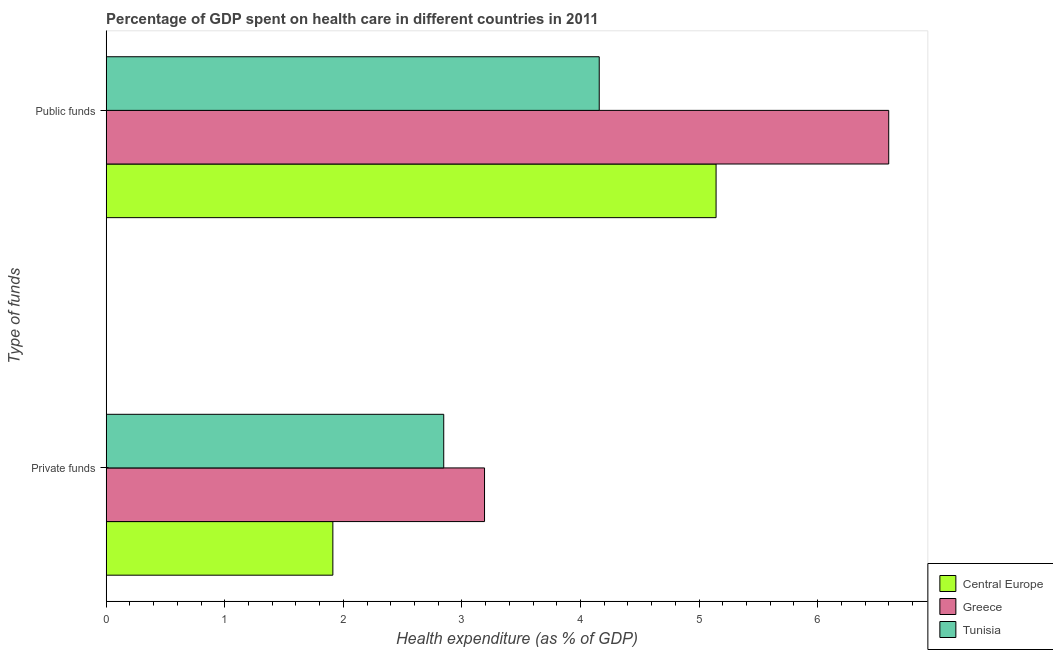How many different coloured bars are there?
Offer a terse response. 3. How many groups of bars are there?
Provide a short and direct response. 2. How many bars are there on the 2nd tick from the bottom?
Make the answer very short. 3. What is the label of the 2nd group of bars from the top?
Ensure brevity in your answer.  Private funds. What is the amount of public funds spent in healthcare in Greece?
Make the answer very short. 6.6. Across all countries, what is the maximum amount of private funds spent in healthcare?
Offer a very short reply. 3.19. Across all countries, what is the minimum amount of public funds spent in healthcare?
Offer a terse response. 4.16. In which country was the amount of private funds spent in healthcare minimum?
Provide a succinct answer. Central Europe. What is the total amount of public funds spent in healthcare in the graph?
Provide a succinct answer. 15.9. What is the difference between the amount of public funds spent in healthcare in Tunisia and that in Greece?
Provide a succinct answer. -2.44. What is the difference between the amount of private funds spent in healthcare in Central Europe and the amount of public funds spent in healthcare in Tunisia?
Your answer should be compact. -2.25. What is the average amount of public funds spent in healthcare per country?
Offer a terse response. 5.3. What is the difference between the amount of public funds spent in healthcare and amount of private funds spent in healthcare in Tunisia?
Give a very brief answer. 1.31. What is the ratio of the amount of private funds spent in healthcare in Greece to that in Central Europe?
Provide a short and direct response. 1.67. What does the 1st bar from the top in Public funds represents?
Your answer should be very brief. Tunisia. What does the 3rd bar from the bottom in Public funds represents?
Your response must be concise. Tunisia. How many bars are there?
Make the answer very short. 6. Are all the bars in the graph horizontal?
Keep it short and to the point. Yes. Are the values on the major ticks of X-axis written in scientific E-notation?
Ensure brevity in your answer.  No. Does the graph contain any zero values?
Keep it short and to the point. No. Does the graph contain grids?
Your response must be concise. No. How many legend labels are there?
Your answer should be very brief. 3. How are the legend labels stacked?
Provide a succinct answer. Vertical. What is the title of the graph?
Give a very brief answer. Percentage of GDP spent on health care in different countries in 2011. Does "Belgium" appear as one of the legend labels in the graph?
Make the answer very short. No. What is the label or title of the X-axis?
Keep it short and to the point. Health expenditure (as % of GDP). What is the label or title of the Y-axis?
Provide a short and direct response. Type of funds. What is the Health expenditure (as % of GDP) in Central Europe in Private funds?
Your answer should be very brief. 1.91. What is the Health expenditure (as % of GDP) of Greece in Private funds?
Offer a very short reply. 3.19. What is the Health expenditure (as % of GDP) of Tunisia in Private funds?
Offer a terse response. 2.85. What is the Health expenditure (as % of GDP) in Central Europe in Public funds?
Offer a terse response. 5.14. What is the Health expenditure (as % of GDP) of Greece in Public funds?
Offer a very short reply. 6.6. What is the Health expenditure (as % of GDP) of Tunisia in Public funds?
Your response must be concise. 4.16. Across all Type of funds, what is the maximum Health expenditure (as % of GDP) in Central Europe?
Provide a succinct answer. 5.14. Across all Type of funds, what is the maximum Health expenditure (as % of GDP) in Greece?
Keep it short and to the point. 6.6. Across all Type of funds, what is the maximum Health expenditure (as % of GDP) of Tunisia?
Your answer should be compact. 4.16. Across all Type of funds, what is the minimum Health expenditure (as % of GDP) of Central Europe?
Offer a very short reply. 1.91. Across all Type of funds, what is the minimum Health expenditure (as % of GDP) of Greece?
Give a very brief answer. 3.19. Across all Type of funds, what is the minimum Health expenditure (as % of GDP) of Tunisia?
Provide a short and direct response. 2.85. What is the total Health expenditure (as % of GDP) of Central Europe in the graph?
Your response must be concise. 7.05. What is the total Health expenditure (as % of GDP) of Greece in the graph?
Make the answer very short. 9.79. What is the total Health expenditure (as % of GDP) in Tunisia in the graph?
Provide a short and direct response. 7. What is the difference between the Health expenditure (as % of GDP) in Central Europe in Private funds and that in Public funds?
Your answer should be compact. -3.23. What is the difference between the Health expenditure (as % of GDP) of Greece in Private funds and that in Public funds?
Your answer should be very brief. -3.41. What is the difference between the Health expenditure (as % of GDP) in Tunisia in Private funds and that in Public funds?
Make the answer very short. -1.31. What is the difference between the Health expenditure (as % of GDP) of Central Europe in Private funds and the Health expenditure (as % of GDP) of Greece in Public funds?
Provide a succinct answer. -4.69. What is the difference between the Health expenditure (as % of GDP) of Central Europe in Private funds and the Health expenditure (as % of GDP) of Tunisia in Public funds?
Your answer should be compact. -2.25. What is the difference between the Health expenditure (as % of GDP) in Greece in Private funds and the Health expenditure (as % of GDP) in Tunisia in Public funds?
Your response must be concise. -0.97. What is the average Health expenditure (as % of GDP) of Central Europe per Type of funds?
Offer a terse response. 3.53. What is the average Health expenditure (as % of GDP) of Greece per Type of funds?
Provide a short and direct response. 4.89. What is the average Health expenditure (as % of GDP) of Tunisia per Type of funds?
Keep it short and to the point. 3.5. What is the difference between the Health expenditure (as % of GDP) of Central Europe and Health expenditure (as % of GDP) of Greece in Private funds?
Your answer should be compact. -1.28. What is the difference between the Health expenditure (as % of GDP) in Central Europe and Health expenditure (as % of GDP) in Tunisia in Private funds?
Your answer should be very brief. -0.93. What is the difference between the Health expenditure (as % of GDP) in Greece and Health expenditure (as % of GDP) in Tunisia in Private funds?
Keep it short and to the point. 0.34. What is the difference between the Health expenditure (as % of GDP) of Central Europe and Health expenditure (as % of GDP) of Greece in Public funds?
Keep it short and to the point. -1.46. What is the difference between the Health expenditure (as % of GDP) in Central Europe and Health expenditure (as % of GDP) in Tunisia in Public funds?
Make the answer very short. 0.99. What is the difference between the Health expenditure (as % of GDP) in Greece and Health expenditure (as % of GDP) in Tunisia in Public funds?
Your response must be concise. 2.44. What is the ratio of the Health expenditure (as % of GDP) in Central Europe in Private funds to that in Public funds?
Offer a terse response. 0.37. What is the ratio of the Health expenditure (as % of GDP) of Greece in Private funds to that in Public funds?
Make the answer very short. 0.48. What is the ratio of the Health expenditure (as % of GDP) of Tunisia in Private funds to that in Public funds?
Offer a very short reply. 0.68. What is the difference between the highest and the second highest Health expenditure (as % of GDP) of Central Europe?
Offer a very short reply. 3.23. What is the difference between the highest and the second highest Health expenditure (as % of GDP) in Greece?
Give a very brief answer. 3.41. What is the difference between the highest and the second highest Health expenditure (as % of GDP) of Tunisia?
Your response must be concise. 1.31. What is the difference between the highest and the lowest Health expenditure (as % of GDP) of Central Europe?
Your response must be concise. 3.23. What is the difference between the highest and the lowest Health expenditure (as % of GDP) in Greece?
Provide a short and direct response. 3.41. What is the difference between the highest and the lowest Health expenditure (as % of GDP) of Tunisia?
Give a very brief answer. 1.31. 